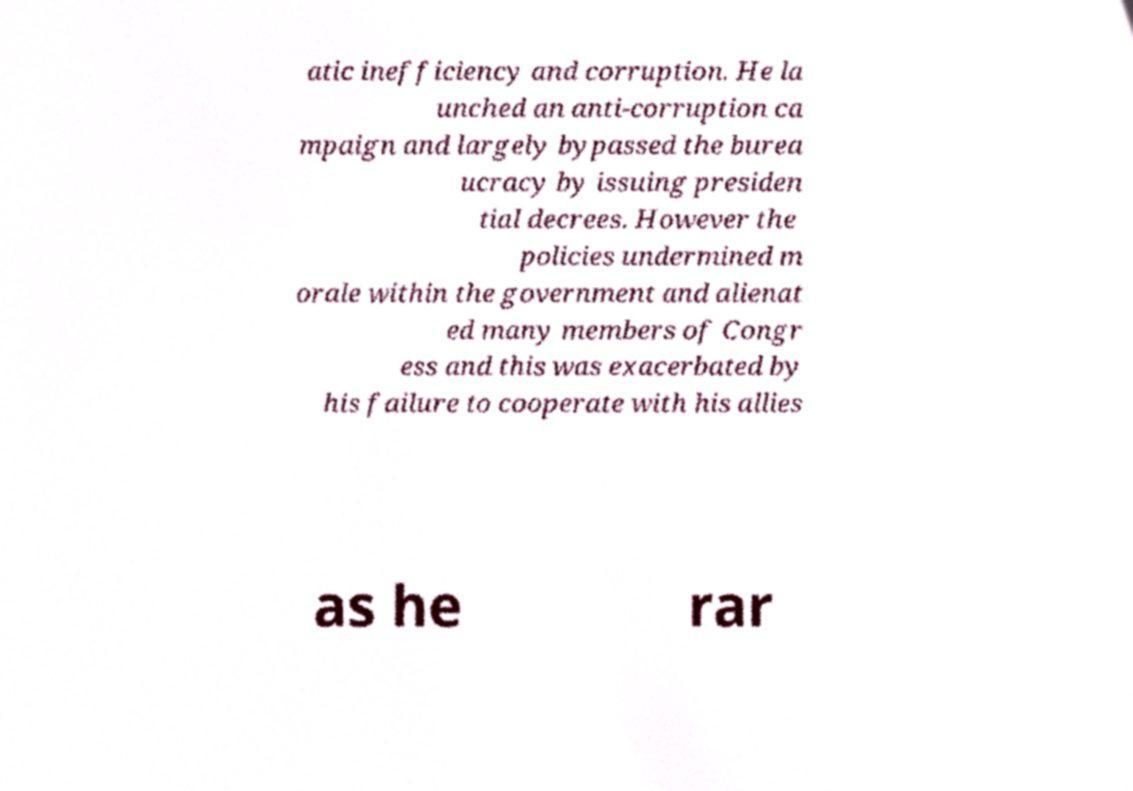Could you assist in decoding the text presented in this image and type it out clearly? atic inefficiency and corruption. He la unched an anti-corruption ca mpaign and largely bypassed the burea ucracy by issuing presiden tial decrees. However the policies undermined m orale within the government and alienat ed many members of Congr ess and this was exacerbated by his failure to cooperate with his allies as he rar 